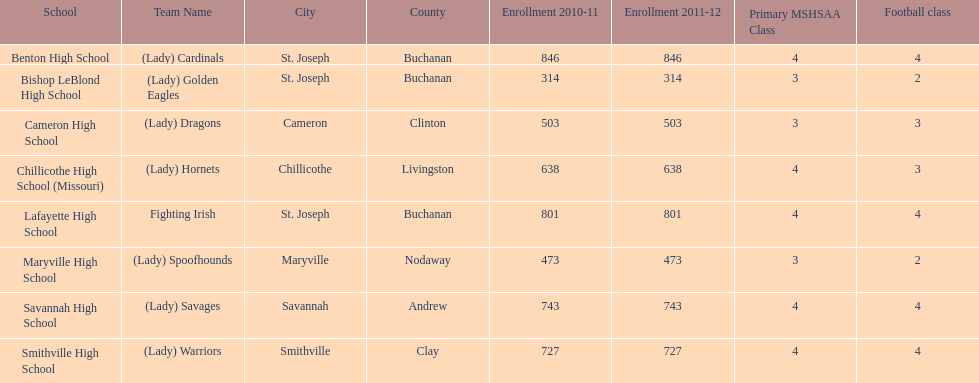Benton high school and bishop leblond high school are both located in what town? St. Joseph. 